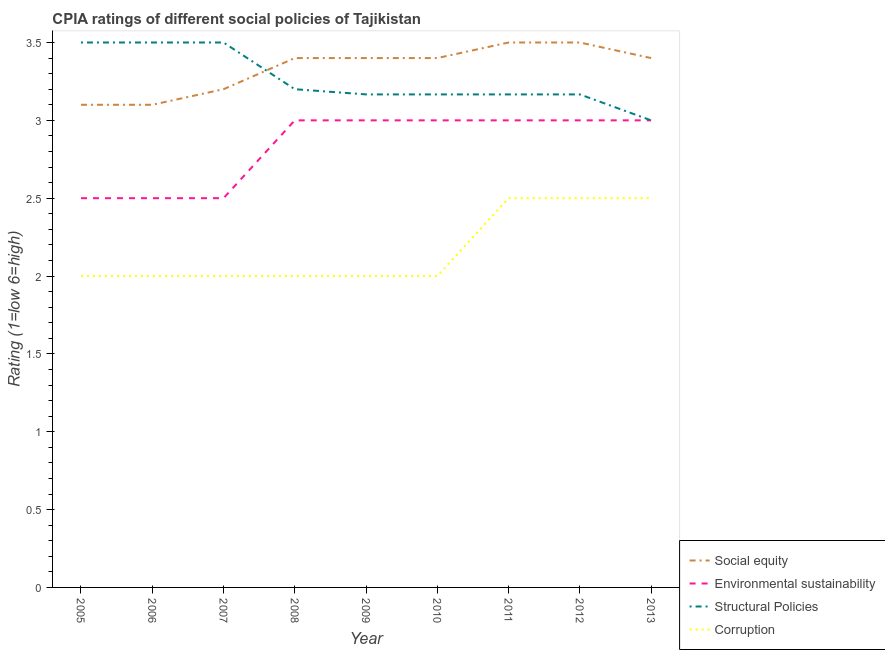How many different coloured lines are there?
Make the answer very short. 4. Does the line corresponding to cpia rating of social equity intersect with the line corresponding to cpia rating of corruption?
Make the answer very short. No. Is the number of lines equal to the number of legend labels?
Offer a very short reply. Yes. What is the cpia rating of corruption in 2008?
Ensure brevity in your answer.  2. Across all years, what is the maximum cpia rating of social equity?
Keep it short and to the point. 3.5. In which year was the cpia rating of social equity maximum?
Ensure brevity in your answer.  2011. What is the difference between the cpia rating of structural policies in 2007 and that in 2011?
Offer a terse response. 0.33. What is the difference between the cpia rating of corruption in 2012 and the cpia rating of environmental sustainability in 2009?
Keep it short and to the point. -0.5. What is the average cpia rating of corruption per year?
Your response must be concise. 2.17. In how many years, is the cpia rating of structural policies greater than 3.1?
Your answer should be very brief. 8. Is the difference between the cpia rating of social equity in 2010 and 2011 greater than the difference between the cpia rating of corruption in 2010 and 2011?
Offer a terse response. Yes. In how many years, is the cpia rating of social equity greater than the average cpia rating of social equity taken over all years?
Make the answer very short. 6. Is it the case that in every year, the sum of the cpia rating of environmental sustainability and cpia rating of structural policies is greater than the sum of cpia rating of social equity and cpia rating of corruption?
Provide a succinct answer. Yes. Does the cpia rating of structural policies monotonically increase over the years?
Your answer should be compact. No. Is the cpia rating of social equity strictly greater than the cpia rating of corruption over the years?
Provide a succinct answer. Yes. How many years are there in the graph?
Give a very brief answer. 9. What is the difference between two consecutive major ticks on the Y-axis?
Provide a short and direct response. 0.5. How are the legend labels stacked?
Offer a terse response. Vertical. What is the title of the graph?
Your answer should be very brief. CPIA ratings of different social policies of Tajikistan. What is the Rating (1=low 6=high) in Social equity in 2005?
Give a very brief answer. 3.1. What is the Rating (1=low 6=high) in Structural Policies in 2005?
Give a very brief answer. 3.5. What is the Rating (1=low 6=high) of Structural Policies in 2006?
Provide a succinct answer. 3.5. What is the Rating (1=low 6=high) of Corruption in 2006?
Give a very brief answer. 2. What is the Rating (1=low 6=high) in Social equity in 2007?
Provide a succinct answer. 3.2. What is the Rating (1=low 6=high) in Structural Policies in 2007?
Offer a terse response. 3.5. What is the Rating (1=low 6=high) in Corruption in 2007?
Your answer should be compact. 2. What is the Rating (1=low 6=high) in Environmental sustainability in 2008?
Make the answer very short. 3. What is the Rating (1=low 6=high) in Corruption in 2008?
Make the answer very short. 2. What is the Rating (1=low 6=high) of Social equity in 2009?
Your answer should be compact. 3.4. What is the Rating (1=low 6=high) in Structural Policies in 2009?
Make the answer very short. 3.17. What is the Rating (1=low 6=high) of Structural Policies in 2010?
Make the answer very short. 3.17. What is the Rating (1=low 6=high) of Environmental sustainability in 2011?
Give a very brief answer. 3. What is the Rating (1=low 6=high) of Structural Policies in 2011?
Provide a succinct answer. 3.17. What is the Rating (1=low 6=high) of Social equity in 2012?
Ensure brevity in your answer.  3.5. What is the Rating (1=low 6=high) of Structural Policies in 2012?
Keep it short and to the point. 3.17. What is the Rating (1=low 6=high) in Corruption in 2012?
Give a very brief answer. 2.5. What is the Rating (1=low 6=high) of Environmental sustainability in 2013?
Keep it short and to the point. 3. Across all years, what is the maximum Rating (1=low 6=high) in Structural Policies?
Make the answer very short. 3.5. Across all years, what is the minimum Rating (1=low 6=high) of Social equity?
Provide a short and direct response. 3.1. Across all years, what is the minimum Rating (1=low 6=high) in Corruption?
Your answer should be compact. 2. What is the total Rating (1=low 6=high) of Structural Policies in the graph?
Make the answer very short. 29.37. What is the total Rating (1=low 6=high) in Corruption in the graph?
Ensure brevity in your answer.  19.5. What is the difference between the Rating (1=low 6=high) of Structural Policies in 2005 and that in 2007?
Offer a terse response. 0. What is the difference between the Rating (1=low 6=high) in Corruption in 2005 and that in 2007?
Provide a short and direct response. 0. What is the difference between the Rating (1=low 6=high) in Social equity in 2005 and that in 2008?
Make the answer very short. -0.3. What is the difference between the Rating (1=low 6=high) of Structural Policies in 2005 and that in 2008?
Offer a terse response. 0.3. What is the difference between the Rating (1=low 6=high) of Corruption in 2005 and that in 2008?
Your response must be concise. 0. What is the difference between the Rating (1=low 6=high) in Social equity in 2005 and that in 2009?
Keep it short and to the point. -0.3. What is the difference between the Rating (1=low 6=high) in Environmental sustainability in 2005 and that in 2009?
Your response must be concise. -0.5. What is the difference between the Rating (1=low 6=high) in Social equity in 2005 and that in 2010?
Your answer should be very brief. -0.3. What is the difference between the Rating (1=low 6=high) in Environmental sustainability in 2005 and that in 2010?
Offer a terse response. -0.5. What is the difference between the Rating (1=low 6=high) in Social equity in 2005 and that in 2011?
Keep it short and to the point. -0.4. What is the difference between the Rating (1=low 6=high) of Environmental sustainability in 2005 and that in 2011?
Your answer should be very brief. -0.5. What is the difference between the Rating (1=low 6=high) of Structural Policies in 2005 and that in 2011?
Your answer should be compact. 0.33. What is the difference between the Rating (1=low 6=high) in Corruption in 2005 and that in 2011?
Ensure brevity in your answer.  -0.5. What is the difference between the Rating (1=low 6=high) in Environmental sustainability in 2005 and that in 2012?
Provide a short and direct response. -0.5. What is the difference between the Rating (1=low 6=high) in Environmental sustainability in 2005 and that in 2013?
Provide a short and direct response. -0.5. What is the difference between the Rating (1=low 6=high) of Social equity in 2006 and that in 2007?
Your response must be concise. -0.1. What is the difference between the Rating (1=low 6=high) in Environmental sustainability in 2006 and that in 2007?
Your answer should be compact. 0. What is the difference between the Rating (1=low 6=high) of Social equity in 2006 and that in 2008?
Offer a very short reply. -0.3. What is the difference between the Rating (1=low 6=high) in Environmental sustainability in 2006 and that in 2008?
Your answer should be very brief. -0.5. What is the difference between the Rating (1=low 6=high) of Structural Policies in 2006 and that in 2008?
Offer a terse response. 0.3. What is the difference between the Rating (1=low 6=high) in Environmental sustainability in 2006 and that in 2009?
Provide a succinct answer. -0.5. What is the difference between the Rating (1=low 6=high) of Structural Policies in 2006 and that in 2009?
Provide a succinct answer. 0.33. What is the difference between the Rating (1=low 6=high) of Environmental sustainability in 2006 and that in 2010?
Your answer should be compact. -0.5. What is the difference between the Rating (1=low 6=high) in Structural Policies in 2006 and that in 2011?
Offer a terse response. 0.33. What is the difference between the Rating (1=low 6=high) of Corruption in 2006 and that in 2011?
Your answer should be compact. -0.5. What is the difference between the Rating (1=low 6=high) of Environmental sustainability in 2006 and that in 2012?
Give a very brief answer. -0.5. What is the difference between the Rating (1=low 6=high) in Corruption in 2006 and that in 2012?
Give a very brief answer. -0.5. What is the difference between the Rating (1=low 6=high) in Environmental sustainability in 2006 and that in 2013?
Your answer should be compact. -0.5. What is the difference between the Rating (1=low 6=high) of Corruption in 2006 and that in 2013?
Your response must be concise. -0.5. What is the difference between the Rating (1=low 6=high) of Environmental sustainability in 2007 and that in 2008?
Make the answer very short. -0.5. What is the difference between the Rating (1=low 6=high) of Structural Policies in 2007 and that in 2008?
Provide a succinct answer. 0.3. What is the difference between the Rating (1=low 6=high) of Social equity in 2007 and that in 2009?
Keep it short and to the point. -0.2. What is the difference between the Rating (1=low 6=high) in Environmental sustainability in 2007 and that in 2009?
Offer a terse response. -0.5. What is the difference between the Rating (1=low 6=high) of Structural Policies in 2007 and that in 2009?
Your answer should be compact. 0.33. What is the difference between the Rating (1=low 6=high) in Corruption in 2007 and that in 2009?
Your answer should be compact. 0. What is the difference between the Rating (1=low 6=high) in Social equity in 2007 and that in 2011?
Your response must be concise. -0.3. What is the difference between the Rating (1=low 6=high) in Environmental sustainability in 2007 and that in 2011?
Keep it short and to the point. -0.5. What is the difference between the Rating (1=low 6=high) of Corruption in 2007 and that in 2011?
Offer a very short reply. -0.5. What is the difference between the Rating (1=low 6=high) in Social equity in 2007 and that in 2012?
Keep it short and to the point. -0.3. What is the difference between the Rating (1=low 6=high) in Environmental sustainability in 2007 and that in 2013?
Provide a succinct answer. -0.5. What is the difference between the Rating (1=low 6=high) in Structural Policies in 2007 and that in 2013?
Keep it short and to the point. 0.5. What is the difference between the Rating (1=low 6=high) of Social equity in 2008 and that in 2009?
Your response must be concise. 0. What is the difference between the Rating (1=low 6=high) in Structural Policies in 2008 and that in 2009?
Make the answer very short. 0.03. What is the difference between the Rating (1=low 6=high) of Environmental sustainability in 2008 and that in 2010?
Your answer should be very brief. 0. What is the difference between the Rating (1=low 6=high) in Structural Policies in 2008 and that in 2010?
Give a very brief answer. 0.03. What is the difference between the Rating (1=low 6=high) of Social equity in 2008 and that in 2012?
Provide a succinct answer. -0.1. What is the difference between the Rating (1=low 6=high) of Environmental sustainability in 2008 and that in 2012?
Your answer should be compact. 0. What is the difference between the Rating (1=low 6=high) in Social equity in 2008 and that in 2013?
Offer a terse response. 0. What is the difference between the Rating (1=low 6=high) of Environmental sustainability in 2009 and that in 2010?
Give a very brief answer. 0. What is the difference between the Rating (1=low 6=high) in Structural Policies in 2009 and that in 2010?
Give a very brief answer. 0. What is the difference between the Rating (1=low 6=high) of Environmental sustainability in 2009 and that in 2011?
Offer a very short reply. 0. What is the difference between the Rating (1=low 6=high) of Corruption in 2009 and that in 2011?
Give a very brief answer. -0.5. What is the difference between the Rating (1=low 6=high) of Environmental sustainability in 2009 and that in 2012?
Your answer should be compact. 0. What is the difference between the Rating (1=low 6=high) of Corruption in 2009 and that in 2012?
Your response must be concise. -0.5. What is the difference between the Rating (1=low 6=high) in Environmental sustainability in 2009 and that in 2013?
Keep it short and to the point. 0. What is the difference between the Rating (1=low 6=high) in Structural Policies in 2009 and that in 2013?
Keep it short and to the point. 0.17. What is the difference between the Rating (1=low 6=high) of Social equity in 2010 and that in 2011?
Make the answer very short. -0.1. What is the difference between the Rating (1=low 6=high) in Social equity in 2010 and that in 2012?
Ensure brevity in your answer.  -0.1. What is the difference between the Rating (1=low 6=high) of Environmental sustainability in 2010 and that in 2012?
Your answer should be compact. 0. What is the difference between the Rating (1=low 6=high) in Corruption in 2010 and that in 2012?
Give a very brief answer. -0.5. What is the difference between the Rating (1=low 6=high) in Structural Policies in 2010 and that in 2013?
Offer a very short reply. 0.17. What is the difference between the Rating (1=low 6=high) of Corruption in 2010 and that in 2013?
Ensure brevity in your answer.  -0.5. What is the difference between the Rating (1=low 6=high) in Social equity in 2011 and that in 2012?
Provide a short and direct response. 0. What is the difference between the Rating (1=low 6=high) of Structural Policies in 2011 and that in 2012?
Ensure brevity in your answer.  0. What is the difference between the Rating (1=low 6=high) in Corruption in 2011 and that in 2012?
Offer a terse response. 0. What is the difference between the Rating (1=low 6=high) in Structural Policies in 2011 and that in 2013?
Make the answer very short. 0.17. What is the difference between the Rating (1=low 6=high) of Corruption in 2011 and that in 2013?
Ensure brevity in your answer.  0. What is the difference between the Rating (1=low 6=high) in Social equity in 2012 and that in 2013?
Your response must be concise. 0.1. What is the difference between the Rating (1=low 6=high) in Corruption in 2012 and that in 2013?
Keep it short and to the point. 0. What is the difference between the Rating (1=low 6=high) of Social equity in 2005 and the Rating (1=low 6=high) of Corruption in 2006?
Your response must be concise. 1.1. What is the difference between the Rating (1=low 6=high) of Environmental sustainability in 2005 and the Rating (1=low 6=high) of Corruption in 2006?
Offer a terse response. 0.5. What is the difference between the Rating (1=low 6=high) in Structural Policies in 2005 and the Rating (1=low 6=high) in Corruption in 2006?
Offer a very short reply. 1.5. What is the difference between the Rating (1=low 6=high) of Social equity in 2005 and the Rating (1=low 6=high) of Environmental sustainability in 2007?
Ensure brevity in your answer.  0.6. What is the difference between the Rating (1=low 6=high) of Social equity in 2005 and the Rating (1=low 6=high) of Corruption in 2007?
Your response must be concise. 1.1. What is the difference between the Rating (1=low 6=high) of Structural Policies in 2005 and the Rating (1=low 6=high) of Corruption in 2007?
Make the answer very short. 1.5. What is the difference between the Rating (1=low 6=high) in Social equity in 2005 and the Rating (1=low 6=high) in Structural Policies in 2008?
Give a very brief answer. -0.1. What is the difference between the Rating (1=low 6=high) of Social equity in 2005 and the Rating (1=low 6=high) of Corruption in 2008?
Your answer should be compact. 1.1. What is the difference between the Rating (1=low 6=high) of Environmental sustainability in 2005 and the Rating (1=low 6=high) of Structural Policies in 2008?
Your response must be concise. -0.7. What is the difference between the Rating (1=low 6=high) in Environmental sustainability in 2005 and the Rating (1=low 6=high) in Corruption in 2008?
Your answer should be very brief. 0.5. What is the difference between the Rating (1=low 6=high) of Structural Policies in 2005 and the Rating (1=low 6=high) of Corruption in 2008?
Keep it short and to the point. 1.5. What is the difference between the Rating (1=low 6=high) of Social equity in 2005 and the Rating (1=low 6=high) of Structural Policies in 2009?
Offer a very short reply. -0.07. What is the difference between the Rating (1=low 6=high) of Structural Policies in 2005 and the Rating (1=low 6=high) of Corruption in 2009?
Make the answer very short. 1.5. What is the difference between the Rating (1=low 6=high) of Social equity in 2005 and the Rating (1=low 6=high) of Structural Policies in 2010?
Offer a terse response. -0.07. What is the difference between the Rating (1=low 6=high) of Social equity in 2005 and the Rating (1=low 6=high) of Corruption in 2010?
Your response must be concise. 1.1. What is the difference between the Rating (1=low 6=high) in Environmental sustainability in 2005 and the Rating (1=low 6=high) in Structural Policies in 2010?
Your answer should be compact. -0.67. What is the difference between the Rating (1=low 6=high) in Environmental sustainability in 2005 and the Rating (1=low 6=high) in Corruption in 2010?
Give a very brief answer. 0.5. What is the difference between the Rating (1=low 6=high) of Social equity in 2005 and the Rating (1=low 6=high) of Environmental sustainability in 2011?
Offer a terse response. 0.1. What is the difference between the Rating (1=low 6=high) in Social equity in 2005 and the Rating (1=low 6=high) in Structural Policies in 2011?
Offer a terse response. -0.07. What is the difference between the Rating (1=low 6=high) in Environmental sustainability in 2005 and the Rating (1=low 6=high) in Corruption in 2011?
Your answer should be compact. 0. What is the difference between the Rating (1=low 6=high) in Structural Policies in 2005 and the Rating (1=low 6=high) in Corruption in 2011?
Offer a terse response. 1. What is the difference between the Rating (1=low 6=high) of Social equity in 2005 and the Rating (1=low 6=high) of Structural Policies in 2012?
Your answer should be compact. -0.07. What is the difference between the Rating (1=low 6=high) in Social equity in 2005 and the Rating (1=low 6=high) in Corruption in 2012?
Offer a terse response. 0.6. What is the difference between the Rating (1=low 6=high) of Social equity in 2005 and the Rating (1=low 6=high) of Environmental sustainability in 2013?
Provide a succinct answer. 0.1. What is the difference between the Rating (1=low 6=high) of Social equity in 2005 and the Rating (1=low 6=high) of Structural Policies in 2013?
Your response must be concise. 0.1. What is the difference between the Rating (1=low 6=high) of Social equity in 2005 and the Rating (1=low 6=high) of Corruption in 2013?
Keep it short and to the point. 0.6. What is the difference between the Rating (1=low 6=high) in Environmental sustainability in 2005 and the Rating (1=low 6=high) in Structural Policies in 2013?
Ensure brevity in your answer.  -0.5. What is the difference between the Rating (1=low 6=high) of Structural Policies in 2005 and the Rating (1=low 6=high) of Corruption in 2013?
Offer a terse response. 1. What is the difference between the Rating (1=low 6=high) of Environmental sustainability in 2006 and the Rating (1=low 6=high) of Structural Policies in 2007?
Your answer should be very brief. -1. What is the difference between the Rating (1=low 6=high) of Structural Policies in 2006 and the Rating (1=low 6=high) of Corruption in 2007?
Your answer should be very brief. 1.5. What is the difference between the Rating (1=low 6=high) in Environmental sustainability in 2006 and the Rating (1=low 6=high) in Structural Policies in 2008?
Give a very brief answer. -0.7. What is the difference between the Rating (1=low 6=high) in Structural Policies in 2006 and the Rating (1=low 6=high) in Corruption in 2008?
Provide a short and direct response. 1.5. What is the difference between the Rating (1=low 6=high) of Social equity in 2006 and the Rating (1=low 6=high) of Environmental sustainability in 2009?
Provide a short and direct response. 0.1. What is the difference between the Rating (1=low 6=high) of Social equity in 2006 and the Rating (1=low 6=high) of Structural Policies in 2009?
Keep it short and to the point. -0.07. What is the difference between the Rating (1=low 6=high) in Environmental sustainability in 2006 and the Rating (1=low 6=high) in Structural Policies in 2009?
Provide a short and direct response. -0.67. What is the difference between the Rating (1=low 6=high) of Social equity in 2006 and the Rating (1=low 6=high) of Environmental sustainability in 2010?
Offer a terse response. 0.1. What is the difference between the Rating (1=low 6=high) of Social equity in 2006 and the Rating (1=low 6=high) of Structural Policies in 2010?
Your answer should be very brief. -0.07. What is the difference between the Rating (1=low 6=high) in Environmental sustainability in 2006 and the Rating (1=low 6=high) in Corruption in 2010?
Your response must be concise. 0.5. What is the difference between the Rating (1=low 6=high) of Social equity in 2006 and the Rating (1=low 6=high) of Structural Policies in 2011?
Make the answer very short. -0.07. What is the difference between the Rating (1=low 6=high) of Social equity in 2006 and the Rating (1=low 6=high) of Corruption in 2011?
Offer a terse response. 0.6. What is the difference between the Rating (1=low 6=high) of Environmental sustainability in 2006 and the Rating (1=low 6=high) of Structural Policies in 2011?
Provide a succinct answer. -0.67. What is the difference between the Rating (1=low 6=high) in Environmental sustainability in 2006 and the Rating (1=low 6=high) in Corruption in 2011?
Provide a succinct answer. 0. What is the difference between the Rating (1=low 6=high) in Structural Policies in 2006 and the Rating (1=low 6=high) in Corruption in 2011?
Make the answer very short. 1. What is the difference between the Rating (1=low 6=high) in Social equity in 2006 and the Rating (1=low 6=high) in Structural Policies in 2012?
Offer a terse response. -0.07. What is the difference between the Rating (1=low 6=high) in Social equity in 2006 and the Rating (1=low 6=high) in Corruption in 2012?
Keep it short and to the point. 0.6. What is the difference between the Rating (1=low 6=high) of Environmental sustainability in 2006 and the Rating (1=low 6=high) of Structural Policies in 2012?
Offer a very short reply. -0.67. What is the difference between the Rating (1=low 6=high) of Environmental sustainability in 2006 and the Rating (1=low 6=high) of Corruption in 2012?
Offer a very short reply. 0. What is the difference between the Rating (1=low 6=high) of Structural Policies in 2006 and the Rating (1=low 6=high) of Corruption in 2012?
Your answer should be compact. 1. What is the difference between the Rating (1=low 6=high) of Social equity in 2006 and the Rating (1=low 6=high) of Corruption in 2013?
Your response must be concise. 0.6. What is the difference between the Rating (1=low 6=high) in Structural Policies in 2006 and the Rating (1=low 6=high) in Corruption in 2013?
Offer a terse response. 1. What is the difference between the Rating (1=low 6=high) in Social equity in 2007 and the Rating (1=low 6=high) in Environmental sustainability in 2008?
Ensure brevity in your answer.  0.2. What is the difference between the Rating (1=low 6=high) in Social equity in 2007 and the Rating (1=low 6=high) in Environmental sustainability in 2009?
Ensure brevity in your answer.  0.2. What is the difference between the Rating (1=low 6=high) of Social equity in 2007 and the Rating (1=low 6=high) of Corruption in 2009?
Provide a succinct answer. 1.2. What is the difference between the Rating (1=low 6=high) in Environmental sustainability in 2007 and the Rating (1=low 6=high) in Structural Policies in 2009?
Give a very brief answer. -0.67. What is the difference between the Rating (1=low 6=high) of Social equity in 2007 and the Rating (1=low 6=high) of Environmental sustainability in 2010?
Provide a short and direct response. 0.2. What is the difference between the Rating (1=low 6=high) of Social equity in 2007 and the Rating (1=low 6=high) of Corruption in 2010?
Offer a very short reply. 1.2. What is the difference between the Rating (1=low 6=high) of Environmental sustainability in 2007 and the Rating (1=low 6=high) of Structural Policies in 2010?
Provide a short and direct response. -0.67. What is the difference between the Rating (1=low 6=high) in Environmental sustainability in 2007 and the Rating (1=low 6=high) in Structural Policies in 2011?
Offer a very short reply. -0.67. What is the difference between the Rating (1=low 6=high) of Structural Policies in 2007 and the Rating (1=low 6=high) of Corruption in 2011?
Provide a short and direct response. 1. What is the difference between the Rating (1=low 6=high) of Social equity in 2007 and the Rating (1=low 6=high) of Environmental sustainability in 2012?
Provide a short and direct response. 0.2. What is the difference between the Rating (1=low 6=high) in Social equity in 2007 and the Rating (1=low 6=high) in Structural Policies in 2012?
Give a very brief answer. 0.03. What is the difference between the Rating (1=low 6=high) in Environmental sustainability in 2007 and the Rating (1=low 6=high) in Corruption in 2012?
Provide a short and direct response. 0. What is the difference between the Rating (1=low 6=high) in Social equity in 2007 and the Rating (1=low 6=high) in Environmental sustainability in 2013?
Provide a succinct answer. 0.2. What is the difference between the Rating (1=low 6=high) of Social equity in 2007 and the Rating (1=low 6=high) of Structural Policies in 2013?
Provide a short and direct response. 0.2. What is the difference between the Rating (1=low 6=high) of Social equity in 2007 and the Rating (1=low 6=high) of Corruption in 2013?
Make the answer very short. 0.7. What is the difference between the Rating (1=low 6=high) of Environmental sustainability in 2007 and the Rating (1=low 6=high) of Structural Policies in 2013?
Offer a terse response. -0.5. What is the difference between the Rating (1=low 6=high) in Environmental sustainability in 2007 and the Rating (1=low 6=high) in Corruption in 2013?
Make the answer very short. 0. What is the difference between the Rating (1=low 6=high) of Structural Policies in 2007 and the Rating (1=low 6=high) of Corruption in 2013?
Ensure brevity in your answer.  1. What is the difference between the Rating (1=low 6=high) in Social equity in 2008 and the Rating (1=low 6=high) in Structural Policies in 2009?
Give a very brief answer. 0.23. What is the difference between the Rating (1=low 6=high) of Environmental sustainability in 2008 and the Rating (1=low 6=high) of Structural Policies in 2009?
Your answer should be very brief. -0.17. What is the difference between the Rating (1=low 6=high) of Environmental sustainability in 2008 and the Rating (1=low 6=high) of Corruption in 2009?
Your answer should be very brief. 1. What is the difference between the Rating (1=low 6=high) of Social equity in 2008 and the Rating (1=low 6=high) of Environmental sustainability in 2010?
Your response must be concise. 0.4. What is the difference between the Rating (1=low 6=high) in Social equity in 2008 and the Rating (1=low 6=high) in Structural Policies in 2010?
Your answer should be very brief. 0.23. What is the difference between the Rating (1=low 6=high) of Social equity in 2008 and the Rating (1=low 6=high) of Corruption in 2010?
Offer a very short reply. 1.4. What is the difference between the Rating (1=low 6=high) of Environmental sustainability in 2008 and the Rating (1=low 6=high) of Corruption in 2010?
Provide a succinct answer. 1. What is the difference between the Rating (1=low 6=high) in Social equity in 2008 and the Rating (1=low 6=high) in Structural Policies in 2011?
Give a very brief answer. 0.23. What is the difference between the Rating (1=low 6=high) in Environmental sustainability in 2008 and the Rating (1=low 6=high) in Corruption in 2011?
Provide a short and direct response. 0.5. What is the difference between the Rating (1=low 6=high) of Structural Policies in 2008 and the Rating (1=low 6=high) of Corruption in 2011?
Your answer should be very brief. 0.7. What is the difference between the Rating (1=low 6=high) in Social equity in 2008 and the Rating (1=low 6=high) in Environmental sustainability in 2012?
Provide a short and direct response. 0.4. What is the difference between the Rating (1=low 6=high) of Social equity in 2008 and the Rating (1=low 6=high) of Structural Policies in 2012?
Your response must be concise. 0.23. What is the difference between the Rating (1=low 6=high) of Social equity in 2008 and the Rating (1=low 6=high) of Corruption in 2012?
Provide a succinct answer. 0.9. What is the difference between the Rating (1=low 6=high) in Environmental sustainability in 2008 and the Rating (1=low 6=high) in Corruption in 2012?
Provide a short and direct response. 0.5. What is the difference between the Rating (1=low 6=high) in Structural Policies in 2008 and the Rating (1=low 6=high) in Corruption in 2012?
Offer a terse response. 0.7. What is the difference between the Rating (1=low 6=high) in Social equity in 2008 and the Rating (1=low 6=high) in Environmental sustainability in 2013?
Keep it short and to the point. 0.4. What is the difference between the Rating (1=low 6=high) in Environmental sustainability in 2008 and the Rating (1=low 6=high) in Structural Policies in 2013?
Give a very brief answer. 0. What is the difference between the Rating (1=low 6=high) of Environmental sustainability in 2008 and the Rating (1=low 6=high) of Corruption in 2013?
Your answer should be very brief. 0.5. What is the difference between the Rating (1=low 6=high) of Social equity in 2009 and the Rating (1=low 6=high) of Environmental sustainability in 2010?
Keep it short and to the point. 0.4. What is the difference between the Rating (1=low 6=high) in Social equity in 2009 and the Rating (1=low 6=high) in Structural Policies in 2010?
Make the answer very short. 0.23. What is the difference between the Rating (1=low 6=high) in Environmental sustainability in 2009 and the Rating (1=low 6=high) in Structural Policies in 2010?
Make the answer very short. -0.17. What is the difference between the Rating (1=low 6=high) in Social equity in 2009 and the Rating (1=low 6=high) in Structural Policies in 2011?
Give a very brief answer. 0.23. What is the difference between the Rating (1=low 6=high) in Environmental sustainability in 2009 and the Rating (1=low 6=high) in Structural Policies in 2011?
Provide a succinct answer. -0.17. What is the difference between the Rating (1=low 6=high) in Environmental sustainability in 2009 and the Rating (1=low 6=high) in Corruption in 2011?
Give a very brief answer. 0.5. What is the difference between the Rating (1=low 6=high) of Social equity in 2009 and the Rating (1=low 6=high) of Structural Policies in 2012?
Offer a terse response. 0.23. What is the difference between the Rating (1=low 6=high) of Social equity in 2009 and the Rating (1=low 6=high) of Corruption in 2012?
Offer a very short reply. 0.9. What is the difference between the Rating (1=low 6=high) in Environmental sustainability in 2009 and the Rating (1=low 6=high) in Corruption in 2012?
Ensure brevity in your answer.  0.5. What is the difference between the Rating (1=low 6=high) in Social equity in 2009 and the Rating (1=low 6=high) in Environmental sustainability in 2013?
Offer a very short reply. 0.4. What is the difference between the Rating (1=low 6=high) of Social equity in 2009 and the Rating (1=low 6=high) of Structural Policies in 2013?
Your answer should be very brief. 0.4. What is the difference between the Rating (1=low 6=high) in Social equity in 2009 and the Rating (1=low 6=high) in Corruption in 2013?
Your response must be concise. 0.9. What is the difference between the Rating (1=low 6=high) in Social equity in 2010 and the Rating (1=low 6=high) in Environmental sustainability in 2011?
Offer a terse response. 0.4. What is the difference between the Rating (1=low 6=high) in Social equity in 2010 and the Rating (1=low 6=high) in Structural Policies in 2011?
Offer a very short reply. 0.23. What is the difference between the Rating (1=low 6=high) of Environmental sustainability in 2010 and the Rating (1=low 6=high) of Corruption in 2011?
Ensure brevity in your answer.  0.5. What is the difference between the Rating (1=low 6=high) in Social equity in 2010 and the Rating (1=low 6=high) in Structural Policies in 2012?
Make the answer very short. 0.23. What is the difference between the Rating (1=low 6=high) of Social equity in 2010 and the Rating (1=low 6=high) of Environmental sustainability in 2013?
Ensure brevity in your answer.  0.4. What is the difference between the Rating (1=low 6=high) of Social equity in 2010 and the Rating (1=low 6=high) of Corruption in 2013?
Provide a short and direct response. 0.9. What is the difference between the Rating (1=low 6=high) in Environmental sustainability in 2010 and the Rating (1=low 6=high) in Structural Policies in 2013?
Your answer should be very brief. 0. What is the difference between the Rating (1=low 6=high) of Environmental sustainability in 2010 and the Rating (1=low 6=high) of Corruption in 2013?
Your answer should be very brief. 0.5. What is the difference between the Rating (1=low 6=high) in Structural Policies in 2010 and the Rating (1=low 6=high) in Corruption in 2013?
Give a very brief answer. 0.67. What is the difference between the Rating (1=low 6=high) of Social equity in 2011 and the Rating (1=low 6=high) of Environmental sustainability in 2012?
Make the answer very short. 0.5. What is the difference between the Rating (1=low 6=high) in Environmental sustainability in 2011 and the Rating (1=low 6=high) in Structural Policies in 2012?
Give a very brief answer. -0.17. What is the difference between the Rating (1=low 6=high) of Social equity in 2011 and the Rating (1=low 6=high) of Environmental sustainability in 2013?
Provide a short and direct response. 0.5. What is the difference between the Rating (1=low 6=high) of Social equity in 2011 and the Rating (1=low 6=high) of Structural Policies in 2013?
Your response must be concise. 0.5. What is the difference between the Rating (1=low 6=high) in Social equity in 2011 and the Rating (1=low 6=high) in Corruption in 2013?
Offer a terse response. 1. What is the difference between the Rating (1=low 6=high) of Environmental sustainability in 2011 and the Rating (1=low 6=high) of Structural Policies in 2013?
Your answer should be very brief. 0. What is the difference between the Rating (1=low 6=high) of Environmental sustainability in 2011 and the Rating (1=low 6=high) of Corruption in 2013?
Offer a terse response. 0.5. What is the difference between the Rating (1=low 6=high) in Social equity in 2012 and the Rating (1=low 6=high) in Environmental sustainability in 2013?
Provide a succinct answer. 0.5. What is the difference between the Rating (1=low 6=high) in Social equity in 2012 and the Rating (1=low 6=high) in Structural Policies in 2013?
Offer a very short reply. 0.5. What is the difference between the Rating (1=low 6=high) in Social equity in 2012 and the Rating (1=low 6=high) in Corruption in 2013?
Give a very brief answer. 1. What is the difference between the Rating (1=low 6=high) in Structural Policies in 2012 and the Rating (1=low 6=high) in Corruption in 2013?
Make the answer very short. 0.67. What is the average Rating (1=low 6=high) of Environmental sustainability per year?
Provide a succinct answer. 2.83. What is the average Rating (1=low 6=high) of Structural Policies per year?
Give a very brief answer. 3.26. What is the average Rating (1=low 6=high) in Corruption per year?
Give a very brief answer. 2.17. In the year 2005, what is the difference between the Rating (1=low 6=high) of Social equity and Rating (1=low 6=high) of Environmental sustainability?
Your answer should be compact. 0.6. In the year 2005, what is the difference between the Rating (1=low 6=high) in Social equity and Rating (1=low 6=high) in Structural Policies?
Provide a succinct answer. -0.4. In the year 2005, what is the difference between the Rating (1=low 6=high) in Structural Policies and Rating (1=low 6=high) in Corruption?
Ensure brevity in your answer.  1.5. In the year 2006, what is the difference between the Rating (1=low 6=high) of Social equity and Rating (1=low 6=high) of Structural Policies?
Give a very brief answer. -0.4. In the year 2006, what is the difference between the Rating (1=low 6=high) in Social equity and Rating (1=low 6=high) in Corruption?
Provide a short and direct response. 1.1. In the year 2006, what is the difference between the Rating (1=low 6=high) in Environmental sustainability and Rating (1=low 6=high) in Structural Policies?
Ensure brevity in your answer.  -1. In the year 2006, what is the difference between the Rating (1=low 6=high) of Environmental sustainability and Rating (1=low 6=high) of Corruption?
Offer a terse response. 0.5. In the year 2006, what is the difference between the Rating (1=low 6=high) of Structural Policies and Rating (1=low 6=high) of Corruption?
Make the answer very short. 1.5. In the year 2007, what is the difference between the Rating (1=low 6=high) in Social equity and Rating (1=low 6=high) in Environmental sustainability?
Offer a terse response. 0.7. In the year 2007, what is the difference between the Rating (1=low 6=high) of Social equity and Rating (1=low 6=high) of Structural Policies?
Your response must be concise. -0.3. In the year 2007, what is the difference between the Rating (1=low 6=high) of Environmental sustainability and Rating (1=low 6=high) of Corruption?
Keep it short and to the point. 0.5. In the year 2007, what is the difference between the Rating (1=low 6=high) of Structural Policies and Rating (1=low 6=high) of Corruption?
Offer a very short reply. 1.5. In the year 2008, what is the difference between the Rating (1=low 6=high) in Social equity and Rating (1=low 6=high) in Structural Policies?
Your response must be concise. 0.2. In the year 2008, what is the difference between the Rating (1=low 6=high) of Social equity and Rating (1=low 6=high) of Corruption?
Your answer should be compact. 1.4. In the year 2008, what is the difference between the Rating (1=low 6=high) of Environmental sustainability and Rating (1=low 6=high) of Structural Policies?
Your response must be concise. -0.2. In the year 2008, what is the difference between the Rating (1=low 6=high) in Environmental sustainability and Rating (1=low 6=high) in Corruption?
Keep it short and to the point. 1. In the year 2008, what is the difference between the Rating (1=low 6=high) in Structural Policies and Rating (1=low 6=high) in Corruption?
Offer a terse response. 1.2. In the year 2009, what is the difference between the Rating (1=low 6=high) in Social equity and Rating (1=low 6=high) in Structural Policies?
Make the answer very short. 0.23. In the year 2009, what is the difference between the Rating (1=low 6=high) of Environmental sustainability and Rating (1=low 6=high) of Structural Policies?
Your response must be concise. -0.17. In the year 2009, what is the difference between the Rating (1=low 6=high) of Structural Policies and Rating (1=low 6=high) of Corruption?
Give a very brief answer. 1.17. In the year 2010, what is the difference between the Rating (1=low 6=high) of Social equity and Rating (1=low 6=high) of Structural Policies?
Offer a terse response. 0.23. In the year 2010, what is the difference between the Rating (1=low 6=high) in Social equity and Rating (1=low 6=high) in Corruption?
Provide a succinct answer. 1.4. In the year 2010, what is the difference between the Rating (1=low 6=high) of Environmental sustainability and Rating (1=low 6=high) of Structural Policies?
Provide a succinct answer. -0.17. In the year 2011, what is the difference between the Rating (1=low 6=high) of Social equity and Rating (1=low 6=high) of Corruption?
Ensure brevity in your answer.  1. In the year 2011, what is the difference between the Rating (1=low 6=high) of Environmental sustainability and Rating (1=low 6=high) of Structural Policies?
Your response must be concise. -0.17. In the year 2011, what is the difference between the Rating (1=low 6=high) in Environmental sustainability and Rating (1=low 6=high) in Corruption?
Offer a very short reply. 0.5. In the year 2012, what is the difference between the Rating (1=low 6=high) of Social equity and Rating (1=low 6=high) of Structural Policies?
Make the answer very short. 0.33. In the year 2012, what is the difference between the Rating (1=low 6=high) of Social equity and Rating (1=low 6=high) of Corruption?
Your answer should be very brief. 1. In the year 2012, what is the difference between the Rating (1=low 6=high) in Environmental sustainability and Rating (1=low 6=high) in Structural Policies?
Ensure brevity in your answer.  -0.17. In the year 2013, what is the difference between the Rating (1=low 6=high) of Social equity and Rating (1=low 6=high) of Structural Policies?
Your answer should be very brief. 0.4. In the year 2013, what is the difference between the Rating (1=low 6=high) of Environmental sustainability and Rating (1=low 6=high) of Structural Policies?
Provide a succinct answer. 0. In the year 2013, what is the difference between the Rating (1=low 6=high) of Structural Policies and Rating (1=low 6=high) of Corruption?
Provide a short and direct response. 0.5. What is the ratio of the Rating (1=low 6=high) in Corruption in 2005 to that in 2006?
Keep it short and to the point. 1. What is the ratio of the Rating (1=low 6=high) in Social equity in 2005 to that in 2007?
Provide a succinct answer. 0.97. What is the ratio of the Rating (1=low 6=high) of Corruption in 2005 to that in 2007?
Give a very brief answer. 1. What is the ratio of the Rating (1=low 6=high) in Social equity in 2005 to that in 2008?
Ensure brevity in your answer.  0.91. What is the ratio of the Rating (1=low 6=high) of Structural Policies in 2005 to that in 2008?
Keep it short and to the point. 1.09. What is the ratio of the Rating (1=low 6=high) in Social equity in 2005 to that in 2009?
Ensure brevity in your answer.  0.91. What is the ratio of the Rating (1=low 6=high) of Environmental sustainability in 2005 to that in 2009?
Offer a very short reply. 0.83. What is the ratio of the Rating (1=low 6=high) in Structural Policies in 2005 to that in 2009?
Provide a short and direct response. 1.11. What is the ratio of the Rating (1=low 6=high) of Corruption in 2005 to that in 2009?
Keep it short and to the point. 1. What is the ratio of the Rating (1=low 6=high) of Social equity in 2005 to that in 2010?
Provide a short and direct response. 0.91. What is the ratio of the Rating (1=low 6=high) of Structural Policies in 2005 to that in 2010?
Ensure brevity in your answer.  1.11. What is the ratio of the Rating (1=low 6=high) of Corruption in 2005 to that in 2010?
Ensure brevity in your answer.  1. What is the ratio of the Rating (1=low 6=high) in Social equity in 2005 to that in 2011?
Offer a terse response. 0.89. What is the ratio of the Rating (1=low 6=high) of Environmental sustainability in 2005 to that in 2011?
Your response must be concise. 0.83. What is the ratio of the Rating (1=low 6=high) of Structural Policies in 2005 to that in 2011?
Your answer should be very brief. 1.11. What is the ratio of the Rating (1=low 6=high) of Social equity in 2005 to that in 2012?
Your response must be concise. 0.89. What is the ratio of the Rating (1=low 6=high) of Structural Policies in 2005 to that in 2012?
Your answer should be compact. 1.11. What is the ratio of the Rating (1=low 6=high) in Social equity in 2005 to that in 2013?
Offer a terse response. 0.91. What is the ratio of the Rating (1=low 6=high) in Structural Policies in 2005 to that in 2013?
Give a very brief answer. 1.17. What is the ratio of the Rating (1=low 6=high) in Corruption in 2005 to that in 2013?
Make the answer very short. 0.8. What is the ratio of the Rating (1=low 6=high) of Social equity in 2006 to that in 2007?
Ensure brevity in your answer.  0.97. What is the ratio of the Rating (1=low 6=high) in Environmental sustainability in 2006 to that in 2007?
Ensure brevity in your answer.  1. What is the ratio of the Rating (1=low 6=high) in Social equity in 2006 to that in 2008?
Provide a short and direct response. 0.91. What is the ratio of the Rating (1=low 6=high) in Structural Policies in 2006 to that in 2008?
Your answer should be very brief. 1.09. What is the ratio of the Rating (1=low 6=high) in Corruption in 2006 to that in 2008?
Your response must be concise. 1. What is the ratio of the Rating (1=low 6=high) in Social equity in 2006 to that in 2009?
Keep it short and to the point. 0.91. What is the ratio of the Rating (1=low 6=high) of Environmental sustainability in 2006 to that in 2009?
Offer a very short reply. 0.83. What is the ratio of the Rating (1=low 6=high) of Structural Policies in 2006 to that in 2009?
Make the answer very short. 1.11. What is the ratio of the Rating (1=low 6=high) of Corruption in 2006 to that in 2009?
Give a very brief answer. 1. What is the ratio of the Rating (1=low 6=high) of Social equity in 2006 to that in 2010?
Your answer should be very brief. 0.91. What is the ratio of the Rating (1=low 6=high) in Structural Policies in 2006 to that in 2010?
Provide a succinct answer. 1.11. What is the ratio of the Rating (1=low 6=high) in Social equity in 2006 to that in 2011?
Ensure brevity in your answer.  0.89. What is the ratio of the Rating (1=low 6=high) of Environmental sustainability in 2006 to that in 2011?
Keep it short and to the point. 0.83. What is the ratio of the Rating (1=low 6=high) of Structural Policies in 2006 to that in 2011?
Ensure brevity in your answer.  1.11. What is the ratio of the Rating (1=low 6=high) in Social equity in 2006 to that in 2012?
Your answer should be very brief. 0.89. What is the ratio of the Rating (1=low 6=high) of Environmental sustainability in 2006 to that in 2012?
Provide a succinct answer. 0.83. What is the ratio of the Rating (1=low 6=high) of Structural Policies in 2006 to that in 2012?
Keep it short and to the point. 1.11. What is the ratio of the Rating (1=low 6=high) in Corruption in 2006 to that in 2012?
Provide a short and direct response. 0.8. What is the ratio of the Rating (1=low 6=high) of Social equity in 2006 to that in 2013?
Offer a very short reply. 0.91. What is the ratio of the Rating (1=low 6=high) of Structural Policies in 2006 to that in 2013?
Your response must be concise. 1.17. What is the ratio of the Rating (1=low 6=high) of Social equity in 2007 to that in 2008?
Offer a very short reply. 0.94. What is the ratio of the Rating (1=low 6=high) in Structural Policies in 2007 to that in 2008?
Keep it short and to the point. 1.09. What is the ratio of the Rating (1=low 6=high) in Social equity in 2007 to that in 2009?
Provide a short and direct response. 0.94. What is the ratio of the Rating (1=low 6=high) in Structural Policies in 2007 to that in 2009?
Offer a very short reply. 1.11. What is the ratio of the Rating (1=low 6=high) in Social equity in 2007 to that in 2010?
Your response must be concise. 0.94. What is the ratio of the Rating (1=low 6=high) of Structural Policies in 2007 to that in 2010?
Make the answer very short. 1.11. What is the ratio of the Rating (1=low 6=high) of Corruption in 2007 to that in 2010?
Make the answer very short. 1. What is the ratio of the Rating (1=low 6=high) of Social equity in 2007 to that in 2011?
Make the answer very short. 0.91. What is the ratio of the Rating (1=low 6=high) in Environmental sustainability in 2007 to that in 2011?
Your answer should be very brief. 0.83. What is the ratio of the Rating (1=low 6=high) of Structural Policies in 2007 to that in 2011?
Your response must be concise. 1.11. What is the ratio of the Rating (1=low 6=high) in Corruption in 2007 to that in 2011?
Give a very brief answer. 0.8. What is the ratio of the Rating (1=low 6=high) in Social equity in 2007 to that in 2012?
Make the answer very short. 0.91. What is the ratio of the Rating (1=low 6=high) in Structural Policies in 2007 to that in 2012?
Give a very brief answer. 1.11. What is the ratio of the Rating (1=low 6=high) of Corruption in 2007 to that in 2012?
Your answer should be compact. 0.8. What is the ratio of the Rating (1=low 6=high) in Corruption in 2007 to that in 2013?
Offer a very short reply. 0.8. What is the ratio of the Rating (1=low 6=high) of Environmental sustainability in 2008 to that in 2009?
Provide a succinct answer. 1. What is the ratio of the Rating (1=low 6=high) of Structural Policies in 2008 to that in 2009?
Make the answer very short. 1.01. What is the ratio of the Rating (1=low 6=high) in Social equity in 2008 to that in 2010?
Provide a succinct answer. 1. What is the ratio of the Rating (1=low 6=high) in Environmental sustainability in 2008 to that in 2010?
Your response must be concise. 1. What is the ratio of the Rating (1=low 6=high) in Structural Policies in 2008 to that in 2010?
Your answer should be very brief. 1.01. What is the ratio of the Rating (1=low 6=high) of Corruption in 2008 to that in 2010?
Give a very brief answer. 1. What is the ratio of the Rating (1=low 6=high) in Social equity in 2008 to that in 2011?
Your answer should be very brief. 0.97. What is the ratio of the Rating (1=low 6=high) of Environmental sustainability in 2008 to that in 2011?
Your answer should be compact. 1. What is the ratio of the Rating (1=low 6=high) in Structural Policies in 2008 to that in 2011?
Make the answer very short. 1.01. What is the ratio of the Rating (1=low 6=high) of Social equity in 2008 to that in 2012?
Make the answer very short. 0.97. What is the ratio of the Rating (1=low 6=high) in Structural Policies in 2008 to that in 2012?
Ensure brevity in your answer.  1.01. What is the ratio of the Rating (1=low 6=high) of Environmental sustainability in 2008 to that in 2013?
Offer a terse response. 1. What is the ratio of the Rating (1=low 6=high) of Structural Policies in 2008 to that in 2013?
Your answer should be compact. 1.07. What is the ratio of the Rating (1=low 6=high) in Corruption in 2008 to that in 2013?
Make the answer very short. 0.8. What is the ratio of the Rating (1=low 6=high) of Social equity in 2009 to that in 2010?
Offer a terse response. 1. What is the ratio of the Rating (1=low 6=high) of Environmental sustainability in 2009 to that in 2010?
Your answer should be compact. 1. What is the ratio of the Rating (1=low 6=high) of Structural Policies in 2009 to that in 2010?
Your response must be concise. 1. What is the ratio of the Rating (1=low 6=high) in Social equity in 2009 to that in 2011?
Your answer should be compact. 0.97. What is the ratio of the Rating (1=low 6=high) in Structural Policies in 2009 to that in 2011?
Your response must be concise. 1. What is the ratio of the Rating (1=low 6=high) of Corruption in 2009 to that in 2011?
Provide a succinct answer. 0.8. What is the ratio of the Rating (1=low 6=high) in Social equity in 2009 to that in 2012?
Your answer should be compact. 0.97. What is the ratio of the Rating (1=low 6=high) in Environmental sustainability in 2009 to that in 2012?
Ensure brevity in your answer.  1. What is the ratio of the Rating (1=low 6=high) of Social equity in 2009 to that in 2013?
Make the answer very short. 1. What is the ratio of the Rating (1=low 6=high) of Environmental sustainability in 2009 to that in 2013?
Offer a very short reply. 1. What is the ratio of the Rating (1=low 6=high) of Structural Policies in 2009 to that in 2013?
Give a very brief answer. 1.06. What is the ratio of the Rating (1=low 6=high) of Social equity in 2010 to that in 2011?
Keep it short and to the point. 0.97. What is the ratio of the Rating (1=low 6=high) of Environmental sustainability in 2010 to that in 2011?
Provide a short and direct response. 1. What is the ratio of the Rating (1=low 6=high) of Corruption in 2010 to that in 2011?
Ensure brevity in your answer.  0.8. What is the ratio of the Rating (1=low 6=high) in Social equity in 2010 to that in 2012?
Your answer should be compact. 0.97. What is the ratio of the Rating (1=low 6=high) in Environmental sustainability in 2010 to that in 2012?
Provide a succinct answer. 1. What is the ratio of the Rating (1=low 6=high) of Structural Policies in 2010 to that in 2012?
Offer a terse response. 1. What is the ratio of the Rating (1=low 6=high) of Corruption in 2010 to that in 2012?
Make the answer very short. 0.8. What is the ratio of the Rating (1=low 6=high) of Structural Policies in 2010 to that in 2013?
Give a very brief answer. 1.06. What is the ratio of the Rating (1=low 6=high) of Corruption in 2010 to that in 2013?
Offer a terse response. 0.8. What is the ratio of the Rating (1=low 6=high) of Social equity in 2011 to that in 2012?
Keep it short and to the point. 1. What is the ratio of the Rating (1=low 6=high) in Environmental sustainability in 2011 to that in 2012?
Offer a terse response. 1. What is the ratio of the Rating (1=low 6=high) of Structural Policies in 2011 to that in 2012?
Offer a terse response. 1. What is the ratio of the Rating (1=low 6=high) of Corruption in 2011 to that in 2012?
Ensure brevity in your answer.  1. What is the ratio of the Rating (1=low 6=high) of Social equity in 2011 to that in 2013?
Provide a short and direct response. 1.03. What is the ratio of the Rating (1=low 6=high) in Environmental sustainability in 2011 to that in 2013?
Your response must be concise. 1. What is the ratio of the Rating (1=low 6=high) of Structural Policies in 2011 to that in 2013?
Keep it short and to the point. 1.06. What is the ratio of the Rating (1=low 6=high) in Corruption in 2011 to that in 2013?
Offer a very short reply. 1. What is the ratio of the Rating (1=low 6=high) of Social equity in 2012 to that in 2013?
Offer a terse response. 1.03. What is the ratio of the Rating (1=low 6=high) of Structural Policies in 2012 to that in 2013?
Make the answer very short. 1.06. What is the difference between the highest and the second highest Rating (1=low 6=high) of Environmental sustainability?
Offer a very short reply. 0. What is the difference between the highest and the second highest Rating (1=low 6=high) of Structural Policies?
Give a very brief answer. 0. What is the difference between the highest and the lowest Rating (1=low 6=high) in Social equity?
Provide a succinct answer. 0.4. What is the difference between the highest and the lowest Rating (1=low 6=high) of Structural Policies?
Give a very brief answer. 0.5. 